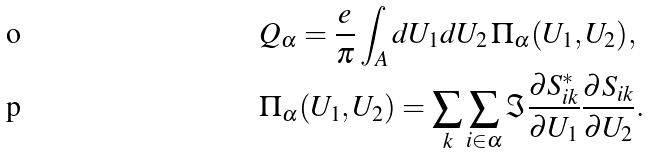<formula> <loc_0><loc_0><loc_500><loc_500>& Q _ { \alpha } = \frac { e } { \pi } \int _ { A } d U _ { 1 } d U _ { 2 } \, \Pi _ { \alpha } ( U _ { 1 } , U _ { 2 } ) , \\ & \Pi _ { \alpha } ( U _ { 1 } , U _ { 2 } ) = \sum _ { k } \sum _ { i \in \alpha } \Im \frac { \partial S _ { i k } ^ { * } } { \partial U _ { 1 } } \frac { \partial S _ { i k } } { \partial U _ { 2 } } .</formula> 